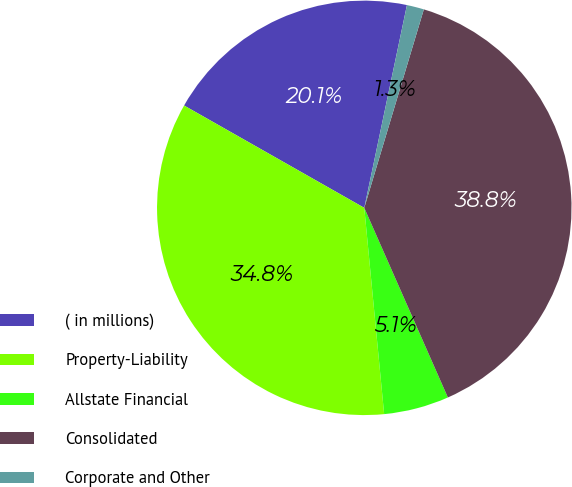Convert chart to OTSL. <chart><loc_0><loc_0><loc_500><loc_500><pie_chart><fcel>( in millions)<fcel>Property-Liability<fcel>Allstate Financial<fcel>Consolidated<fcel>Corporate and Other<nl><fcel>20.08%<fcel>34.75%<fcel>5.08%<fcel>38.75%<fcel>1.34%<nl></chart> 